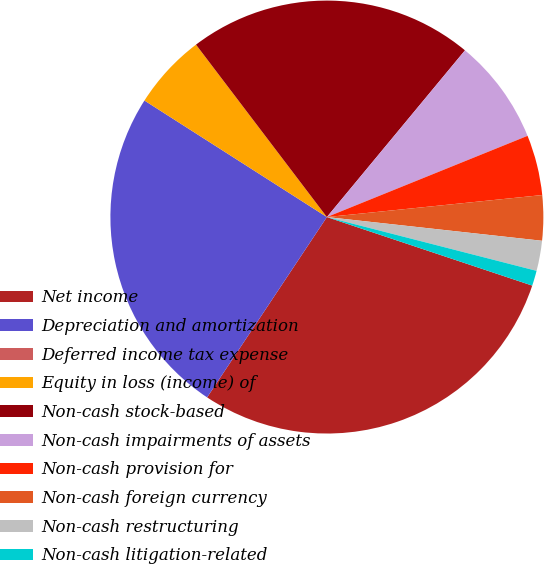<chart> <loc_0><loc_0><loc_500><loc_500><pie_chart><fcel>Net income<fcel>Depreciation and amortization<fcel>Deferred income tax expense<fcel>Equity in loss (income) of<fcel>Non-cash stock-based<fcel>Non-cash impairments of assets<fcel>Non-cash provision for<fcel>Non-cash foreign currency<fcel>Non-cash restructuring<fcel>Non-cash litigation-related<nl><fcel>29.21%<fcel>24.72%<fcel>0.0%<fcel>5.62%<fcel>21.35%<fcel>7.87%<fcel>4.5%<fcel>3.37%<fcel>2.25%<fcel>1.13%<nl></chart> 